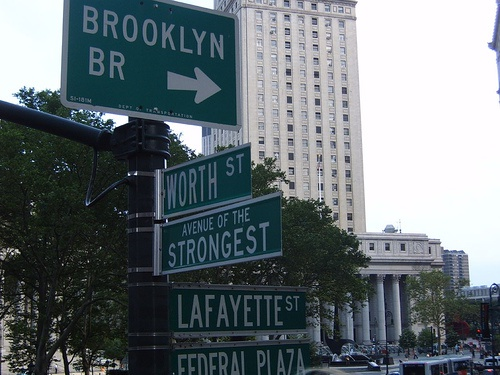Describe the objects in this image and their specific colors. I can see bus in white, black, and gray tones, traffic light in black and white tones, traffic light in black, darkblue, and white tones, people in white, black, gray, and purple tones, and people in white, black, gray, and darkblue tones in this image. 